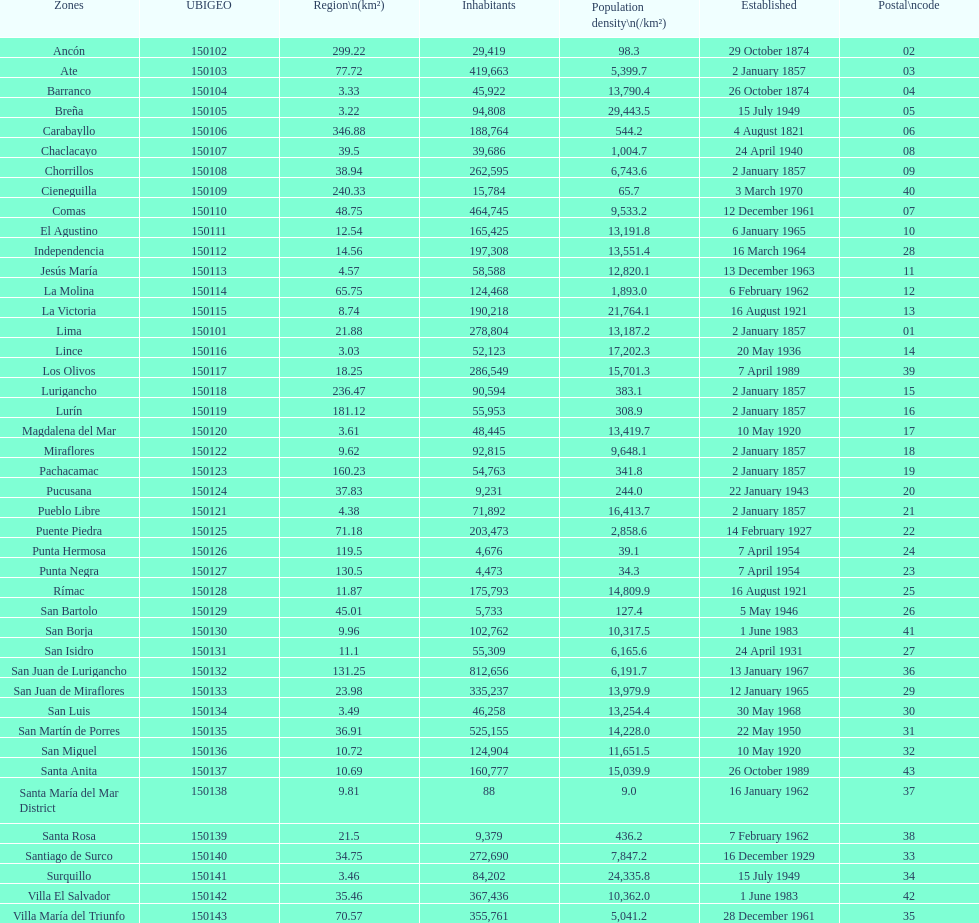What was the last district created? Santa Anita. 